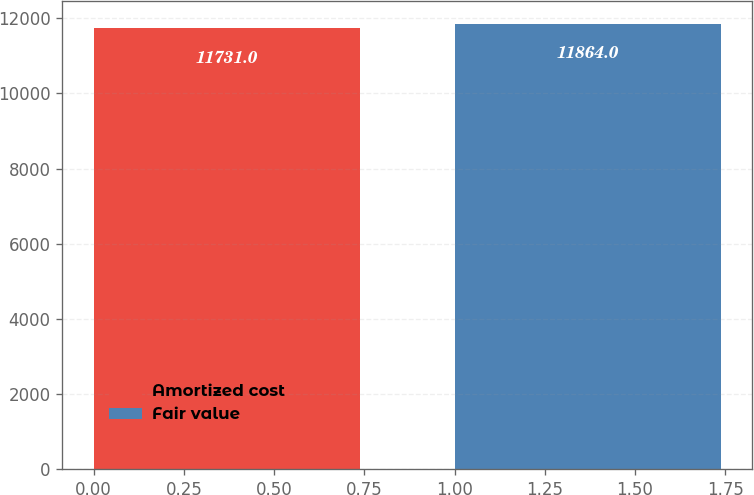<chart> <loc_0><loc_0><loc_500><loc_500><bar_chart><fcel>Amortized cost<fcel>Fair value<nl><fcel>11731<fcel>11864<nl></chart> 